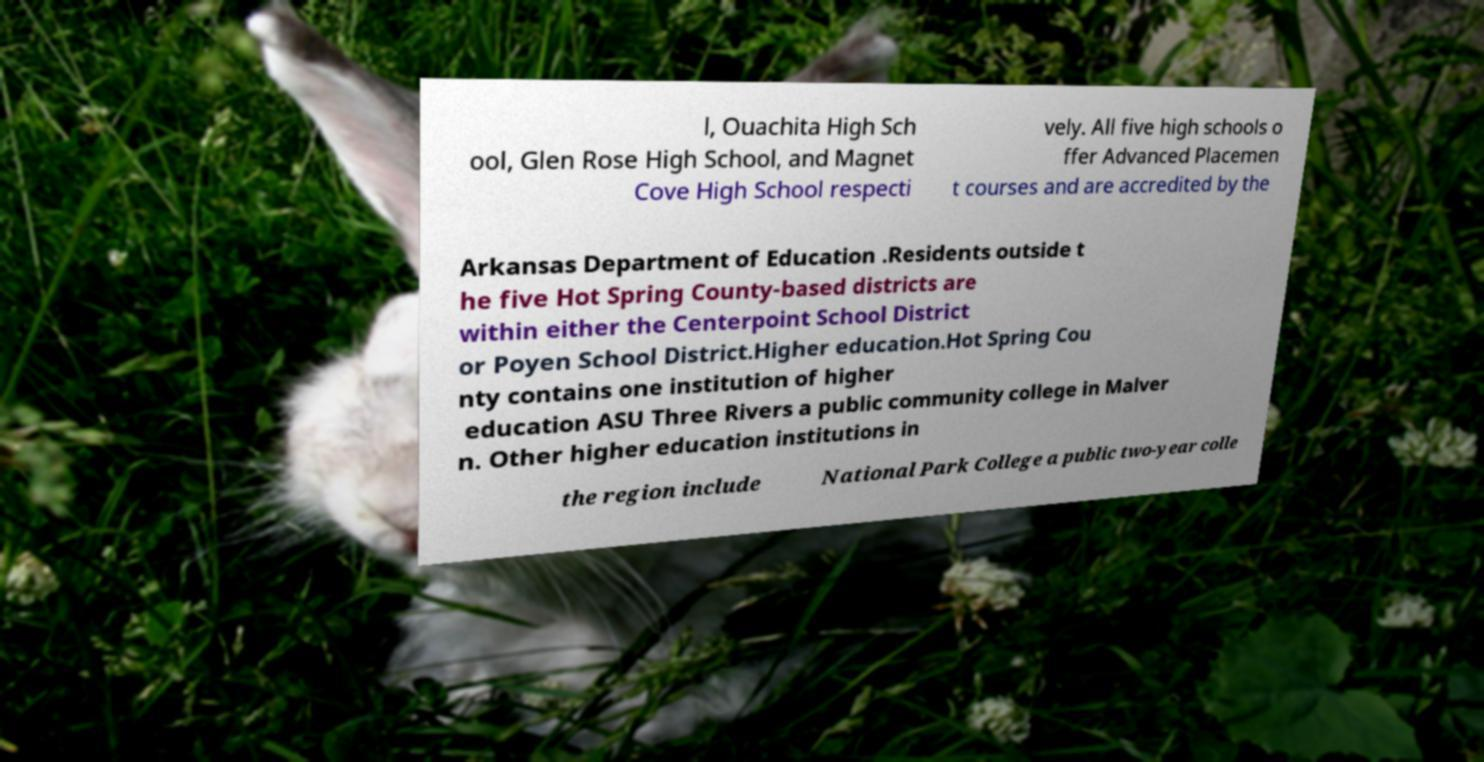Please read and relay the text visible in this image. What does it say? l, Ouachita High Sch ool, Glen Rose High School, and Magnet Cove High School respecti vely. All five high schools o ffer Advanced Placemen t courses and are accredited by the Arkansas Department of Education .Residents outside t he five Hot Spring County-based districts are within either the Centerpoint School District or Poyen School District.Higher education.Hot Spring Cou nty contains one institution of higher education ASU Three Rivers a public community college in Malver n. Other higher education institutions in the region include National Park College a public two-year colle 